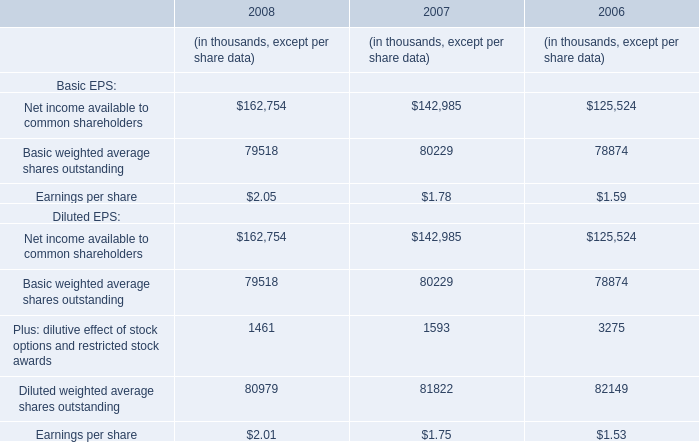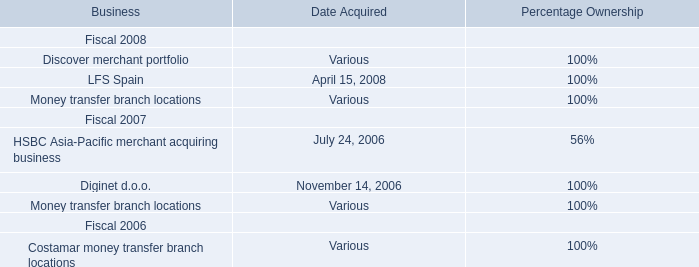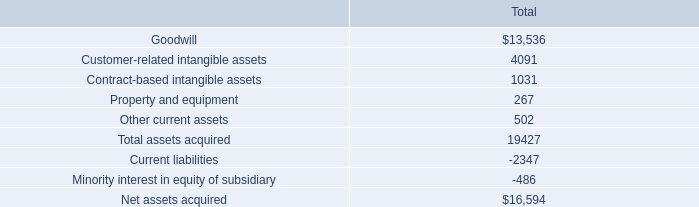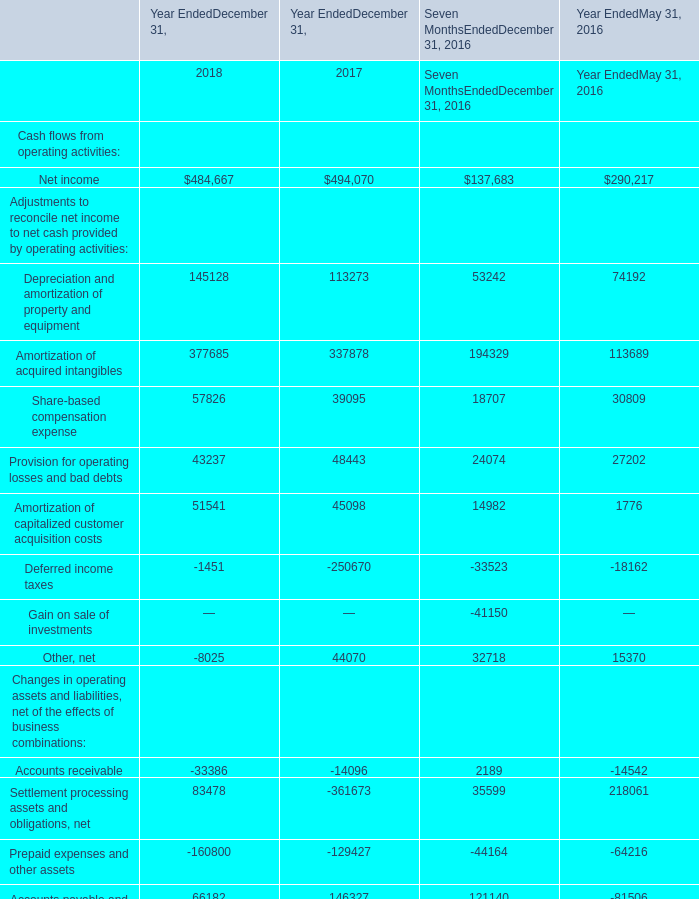what is the average amortization expense related to customer-related intangible assets? 
Computations: (4091 / 14)
Answer: 292.21429. 